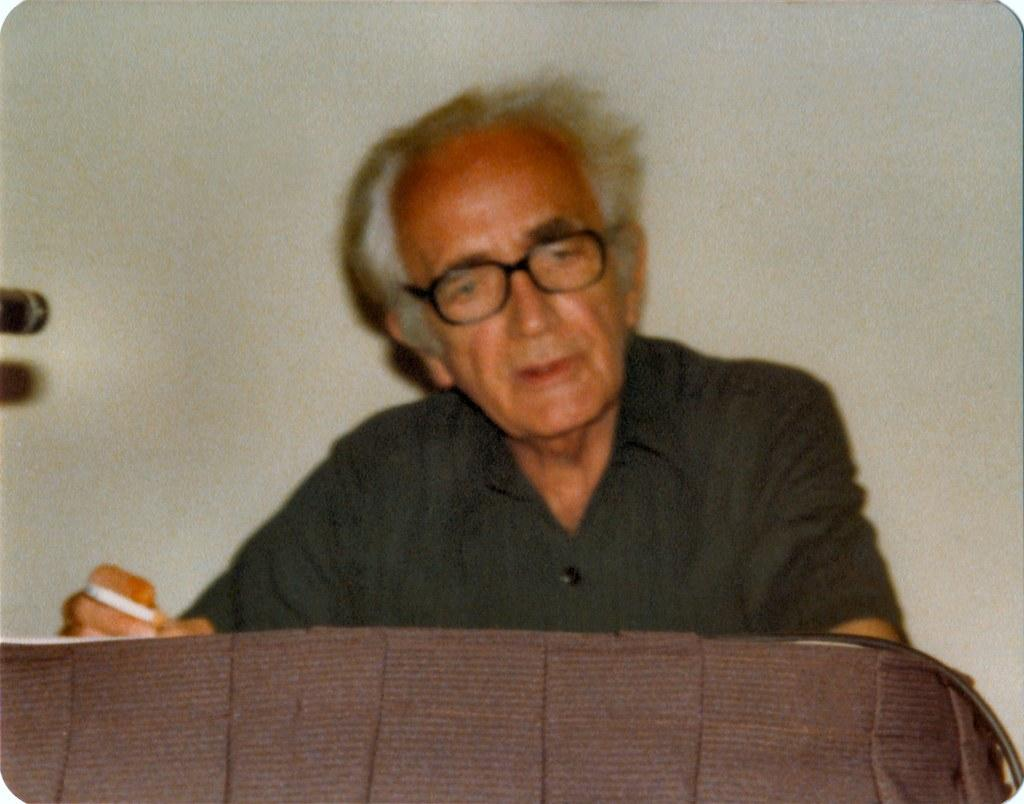Who is present in the image? There is a man in the image. What is the man holding in his hand? The man is holding a cigarette in his hand. What object can be seen in the image that might be used for placing items? There appears to be a table in the image. What can be seen in the background of the image? There is a wall in the background of the image. What type of silver yarn is the man using to knit toys in the image? There is no silver yarn, knitting, or toys present in the image. 